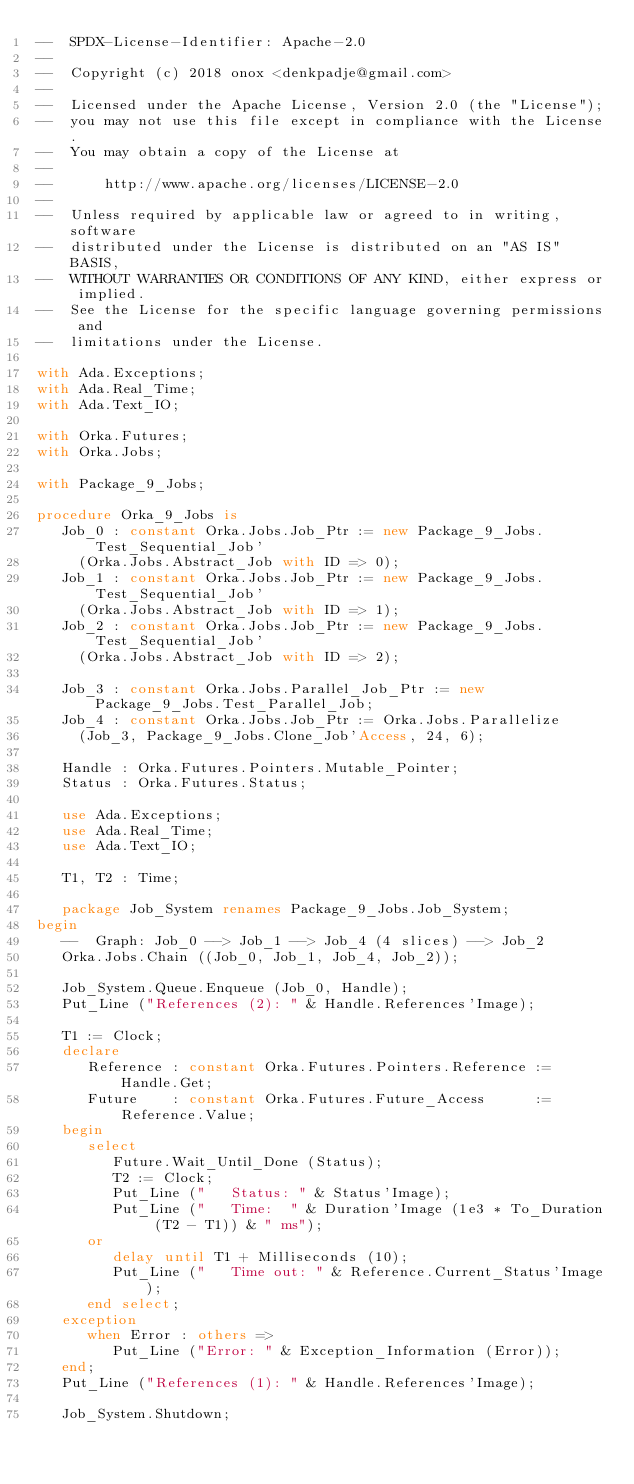<code> <loc_0><loc_0><loc_500><loc_500><_Ada_>--  SPDX-License-Identifier: Apache-2.0
--
--  Copyright (c) 2018 onox <denkpadje@gmail.com>
--
--  Licensed under the Apache License, Version 2.0 (the "License");
--  you may not use this file except in compliance with the License.
--  You may obtain a copy of the License at
--
--      http://www.apache.org/licenses/LICENSE-2.0
--
--  Unless required by applicable law or agreed to in writing, software
--  distributed under the License is distributed on an "AS IS" BASIS,
--  WITHOUT WARRANTIES OR CONDITIONS OF ANY KIND, either express or implied.
--  See the License for the specific language governing permissions and
--  limitations under the License.

with Ada.Exceptions;
with Ada.Real_Time;
with Ada.Text_IO;

with Orka.Futures;
with Orka.Jobs;

with Package_9_Jobs;

procedure Orka_9_Jobs is
   Job_0 : constant Orka.Jobs.Job_Ptr := new Package_9_Jobs.Test_Sequential_Job'
     (Orka.Jobs.Abstract_Job with ID => 0);
   Job_1 : constant Orka.Jobs.Job_Ptr := new Package_9_Jobs.Test_Sequential_Job'
     (Orka.Jobs.Abstract_Job with ID => 1);
   Job_2 : constant Orka.Jobs.Job_Ptr := new Package_9_Jobs.Test_Sequential_Job'
     (Orka.Jobs.Abstract_Job with ID => 2);

   Job_3 : constant Orka.Jobs.Parallel_Job_Ptr := new Package_9_Jobs.Test_Parallel_Job;
   Job_4 : constant Orka.Jobs.Job_Ptr := Orka.Jobs.Parallelize
     (Job_3, Package_9_Jobs.Clone_Job'Access, 24, 6);

   Handle : Orka.Futures.Pointers.Mutable_Pointer;
   Status : Orka.Futures.Status;

   use Ada.Exceptions;
   use Ada.Real_Time;
   use Ada.Text_IO;

   T1, T2 : Time;

   package Job_System renames Package_9_Jobs.Job_System;
begin
   --  Graph: Job_0 --> Job_1 --> Job_4 (4 slices) --> Job_2
   Orka.Jobs.Chain ((Job_0, Job_1, Job_4, Job_2));

   Job_System.Queue.Enqueue (Job_0, Handle);
   Put_Line ("References (2): " & Handle.References'Image);

   T1 := Clock;
   declare
      Reference : constant Orka.Futures.Pointers.Reference := Handle.Get;
      Future    : constant Orka.Futures.Future_Access      := Reference.Value;
   begin
      select
         Future.Wait_Until_Done (Status);
         T2 := Clock;
         Put_Line ("   Status: " & Status'Image);
         Put_Line ("   Time:  " & Duration'Image (1e3 * To_Duration (T2 - T1)) & " ms");
      or
         delay until T1 + Milliseconds (10);
         Put_Line ("   Time out: " & Reference.Current_Status'Image);
      end select;
   exception
      when Error : others =>
         Put_Line ("Error: " & Exception_Information (Error));
   end;
   Put_Line ("References (1): " & Handle.References'Image);

   Job_System.Shutdown;
</code> 